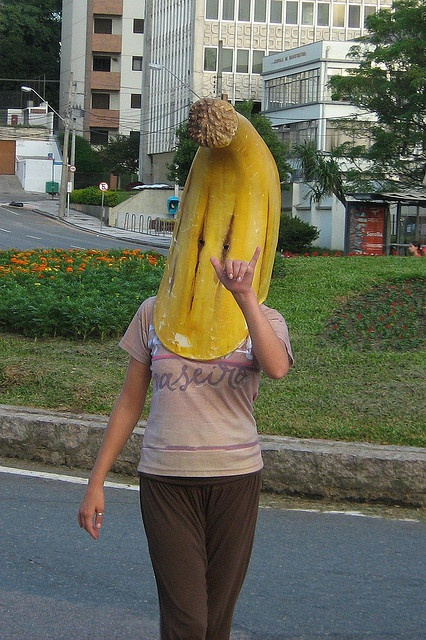Describe the objects in this image and their specific colors. I can see people in gray, black, and darkgray tones and banana in gray, olive, and orange tones in this image. 